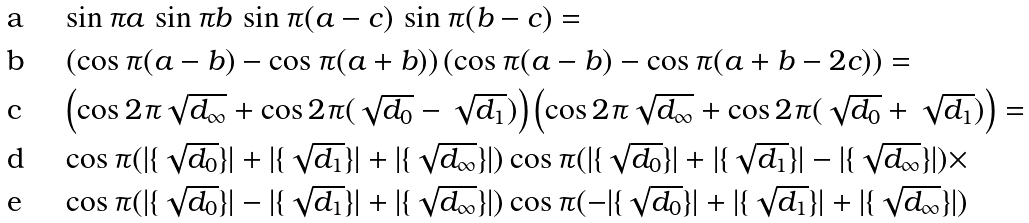<formula> <loc_0><loc_0><loc_500><loc_500>& \sin \pi a \, \sin \pi b \, \sin \pi ( a - c ) \, \sin \pi ( b - c ) = \\ & \left ( \cos \pi ( a - b ) - \cos \pi ( a + b ) \right ) \left ( \cos \pi ( a - b ) - \cos \pi ( a + b - 2 c ) \right ) = \\ & \left ( \cos 2 \pi \sqrt { d _ { \infty } } + \cos 2 \pi ( \sqrt { d _ { 0 } } - \sqrt { d _ { 1 } } ) \right ) \left ( \cos 2 \pi \sqrt { d _ { \infty } } + \cos 2 \pi ( \sqrt { d _ { 0 } } + \sqrt { d _ { 1 } } ) \right ) = \\ & \cos \pi ( | \{ \sqrt { d _ { 0 } } \} | + | \{ \sqrt { d _ { 1 } } \} | + | \{ \sqrt { d _ { \infty } } \} | ) \cos \pi ( | \{ \sqrt { d _ { 0 } } \} | + | \{ \sqrt { d _ { 1 } } \} | - | \{ \sqrt { d _ { \infty } } \} | ) \times \\ & \cos \pi ( | \{ \sqrt { d _ { 0 } } \} | - | \{ \sqrt { d _ { 1 } } \} | + | \{ \sqrt { d _ { \infty } } \} | ) \cos \pi ( - | \{ \sqrt { d _ { 0 } } \} | + | \{ \sqrt { d _ { 1 } } \} | + | \{ \sqrt { d _ { \infty } } \} | )</formula> 